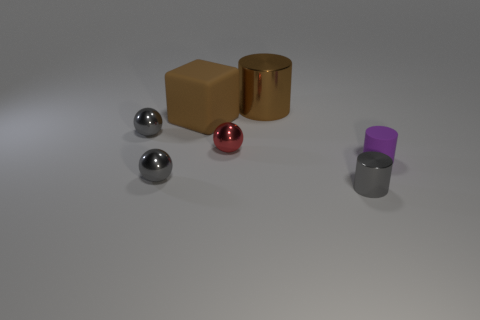There is a metallic ball in front of the tiny purple thing; are there any tiny things that are to the right of it?
Make the answer very short. Yes. How many blocks are either red metallic objects or purple objects?
Provide a succinct answer. 0. There is a rubber object left of the matte thing that is in front of the brown object that is on the left side of the brown metallic cylinder; how big is it?
Keep it short and to the point. Large. Are there any small gray objects in front of the tiny shiny cylinder?
Your response must be concise. No. There is a large thing that is the same color as the large cylinder; what is its shape?
Make the answer very short. Cube. How many things are either small metallic objects on the right side of the big metal cylinder or blue shiny balls?
Provide a succinct answer. 1. The gray cylinder that is made of the same material as the tiny red ball is what size?
Your response must be concise. Small. Does the matte cylinder have the same size as the gray metallic ball in front of the purple rubber cylinder?
Your answer should be very brief. Yes. There is a cylinder that is both in front of the large rubber cube and to the left of the small purple matte object; what is its color?
Give a very brief answer. Gray. How many objects are balls behind the purple object or spheres to the right of the block?
Provide a short and direct response. 2. 